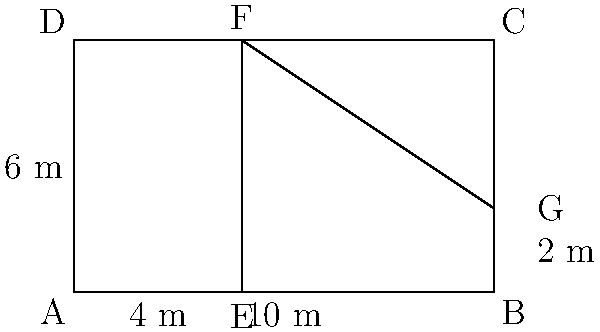In an urban revitalization project, you're tasked with designing the most efficient layout for a rectangular city block measuring 10m by 6m. The block is divided into three sections: two rectangles and one right-angled triangle, as shown in the diagram. If the smaller rectangle has a width of 4m, what is the total perimeter of all three sections combined? To solve this problem, we'll follow these steps:

1. Identify the dimensions of each section:
   - Rectangle 1 (left): 4m x 6m
   - Rectangle 2 (top right): 6m x 2m
   - Triangle (bottom right): base 6m, height 4m

2. Calculate the perimeter of Rectangle 1:
   $P_1 = 2(4m + 6m) = 20m$

3. Calculate the perimeter of Rectangle 2:
   $P_2 = 2(6m + 2m) = 16m$

4. Calculate the perimeter of the Triangle:
   - We need to find the hypotenuse using the Pythagorean theorem:
     $c^2 = 6^2 + 4^2 = 36 + 16 = 52$
     $c = \sqrt{52} = 2\sqrt{13}m$
   - Perimeter of triangle: $P_3 = 6m + 4m + 2\sqrt{13}m = (10 + 2\sqrt{13})m$

5. Sum up the perimeters:
   Total Perimeter $= P_1 + P_2 + P_3$
   $= 20m + 16m + (10 + 2\sqrt{13})m$
   $= (46 + 2\sqrt{13})m$

Therefore, the total perimeter of all three sections combined is $(46 + 2\sqrt{13})m$.
Answer: $(46 + 2\sqrt{13})m$ 